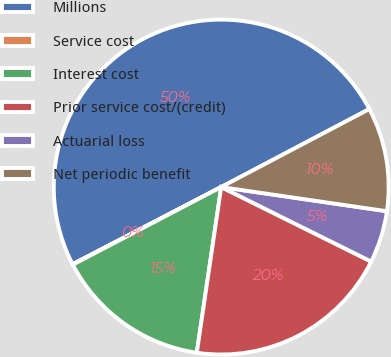Convert chart to OTSL. <chart><loc_0><loc_0><loc_500><loc_500><pie_chart><fcel>Millions<fcel>Service cost<fcel>Interest cost<fcel>Prior service cost/(credit)<fcel>Actuarial loss<fcel>Net periodic benefit<nl><fcel>49.9%<fcel>0.05%<fcel>15.0%<fcel>19.99%<fcel>5.03%<fcel>10.02%<nl></chart> 